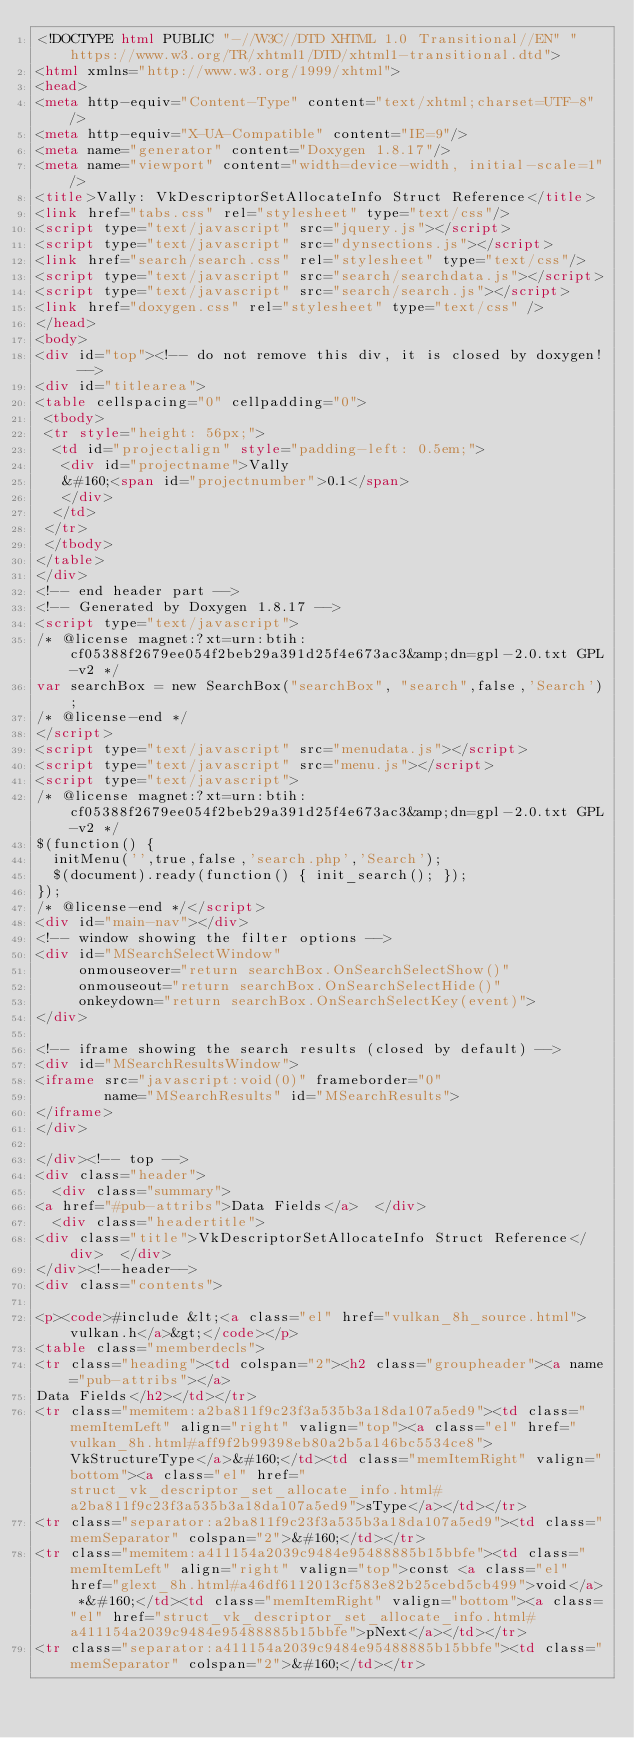Convert code to text. <code><loc_0><loc_0><loc_500><loc_500><_HTML_><!DOCTYPE html PUBLIC "-//W3C//DTD XHTML 1.0 Transitional//EN" "https://www.w3.org/TR/xhtml1/DTD/xhtml1-transitional.dtd">
<html xmlns="http://www.w3.org/1999/xhtml">
<head>
<meta http-equiv="Content-Type" content="text/xhtml;charset=UTF-8"/>
<meta http-equiv="X-UA-Compatible" content="IE=9"/>
<meta name="generator" content="Doxygen 1.8.17"/>
<meta name="viewport" content="width=device-width, initial-scale=1"/>
<title>Vally: VkDescriptorSetAllocateInfo Struct Reference</title>
<link href="tabs.css" rel="stylesheet" type="text/css"/>
<script type="text/javascript" src="jquery.js"></script>
<script type="text/javascript" src="dynsections.js"></script>
<link href="search/search.css" rel="stylesheet" type="text/css"/>
<script type="text/javascript" src="search/searchdata.js"></script>
<script type="text/javascript" src="search/search.js"></script>
<link href="doxygen.css" rel="stylesheet" type="text/css" />
</head>
<body>
<div id="top"><!-- do not remove this div, it is closed by doxygen! -->
<div id="titlearea">
<table cellspacing="0" cellpadding="0">
 <tbody>
 <tr style="height: 56px;">
  <td id="projectalign" style="padding-left: 0.5em;">
   <div id="projectname">Vally
   &#160;<span id="projectnumber">0.1</span>
   </div>
  </td>
 </tr>
 </tbody>
</table>
</div>
<!-- end header part -->
<!-- Generated by Doxygen 1.8.17 -->
<script type="text/javascript">
/* @license magnet:?xt=urn:btih:cf05388f2679ee054f2beb29a391d25f4e673ac3&amp;dn=gpl-2.0.txt GPL-v2 */
var searchBox = new SearchBox("searchBox", "search",false,'Search');
/* @license-end */
</script>
<script type="text/javascript" src="menudata.js"></script>
<script type="text/javascript" src="menu.js"></script>
<script type="text/javascript">
/* @license magnet:?xt=urn:btih:cf05388f2679ee054f2beb29a391d25f4e673ac3&amp;dn=gpl-2.0.txt GPL-v2 */
$(function() {
  initMenu('',true,false,'search.php','Search');
  $(document).ready(function() { init_search(); });
});
/* @license-end */</script>
<div id="main-nav"></div>
<!-- window showing the filter options -->
<div id="MSearchSelectWindow"
     onmouseover="return searchBox.OnSearchSelectShow()"
     onmouseout="return searchBox.OnSearchSelectHide()"
     onkeydown="return searchBox.OnSearchSelectKey(event)">
</div>

<!-- iframe showing the search results (closed by default) -->
<div id="MSearchResultsWindow">
<iframe src="javascript:void(0)" frameborder="0" 
        name="MSearchResults" id="MSearchResults">
</iframe>
</div>

</div><!-- top -->
<div class="header">
  <div class="summary">
<a href="#pub-attribs">Data Fields</a>  </div>
  <div class="headertitle">
<div class="title">VkDescriptorSetAllocateInfo Struct Reference</div>  </div>
</div><!--header-->
<div class="contents">

<p><code>#include &lt;<a class="el" href="vulkan_8h_source.html">vulkan.h</a>&gt;</code></p>
<table class="memberdecls">
<tr class="heading"><td colspan="2"><h2 class="groupheader"><a name="pub-attribs"></a>
Data Fields</h2></td></tr>
<tr class="memitem:a2ba811f9c23f3a535b3a18da107a5ed9"><td class="memItemLeft" align="right" valign="top"><a class="el" href="vulkan_8h.html#aff9f2b99398eb80a2b5a146bc5534ce8">VkStructureType</a>&#160;</td><td class="memItemRight" valign="bottom"><a class="el" href="struct_vk_descriptor_set_allocate_info.html#a2ba811f9c23f3a535b3a18da107a5ed9">sType</a></td></tr>
<tr class="separator:a2ba811f9c23f3a535b3a18da107a5ed9"><td class="memSeparator" colspan="2">&#160;</td></tr>
<tr class="memitem:a411154a2039c9484e95488885b15bbfe"><td class="memItemLeft" align="right" valign="top">const <a class="el" href="glext_8h.html#a46df6112013cf583e82b25cebd5cb499">void</a> *&#160;</td><td class="memItemRight" valign="bottom"><a class="el" href="struct_vk_descriptor_set_allocate_info.html#a411154a2039c9484e95488885b15bbfe">pNext</a></td></tr>
<tr class="separator:a411154a2039c9484e95488885b15bbfe"><td class="memSeparator" colspan="2">&#160;</td></tr></code> 